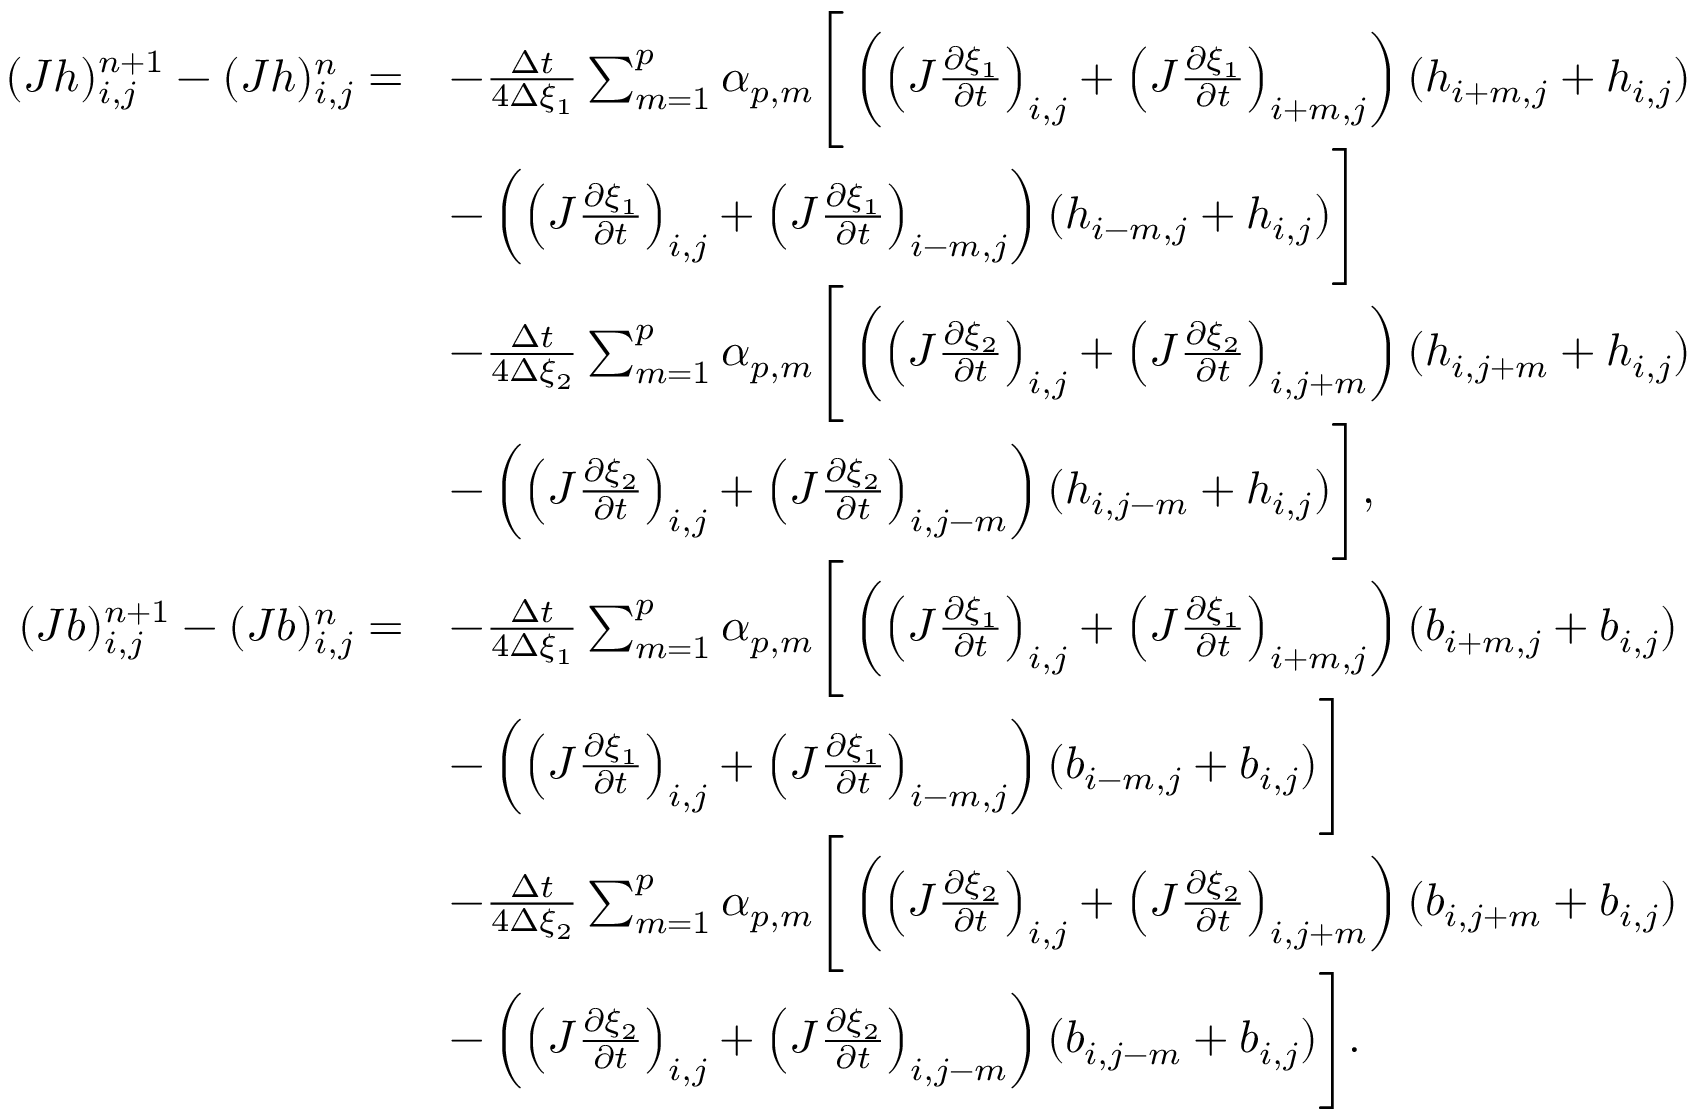Convert formula to latex. <formula><loc_0><loc_0><loc_500><loc_500>\begin{array} { r l } { ( J h ) _ { i , j } ^ { n + 1 } - ( J h ) _ { i , j } ^ { n } = } & { - \frac { \Delta t } { 4 \Delta { \xi _ { 1 } } } \sum _ { m = 1 } ^ { p } \alpha _ { p , m } \left [ \left ( \left ( J \frac { \partial \xi _ { 1 } } { \partial t } \right ) _ { i , j } + \left ( J \frac { \partial \xi _ { 1 } } { \partial t } \right ) _ { i + m , j } \right ) ( h _ { i + m , j } + h _ { i , j } ) } \\ & { - \left ( \left ( J \frac { \partial \xi _ { 1 } } { \partial t } \right ) _ { i , j } + \left ( J \frac { \partial \xi _ { 1 } } { \partial t } \right ) _ { i - m , j } \right ) ( h _ { i - m , j } + h _ { i , j } ) \right ] } \\ & { - \frac { \Delta t } { 4 \Delta { \xi _ { 2 } } } \sum _ { m = 1 } ^ { p } \alpha _ { p , m } \left [ \left ( \left ( J \frac { \partial \xi _ { 2 } } { \partial t } \right ) _ { i , j } + \left ( J \frac { \partial \xi _ { 2 } } { \partial t } \right ) _ { i , j + m } \right ) ( h _ { i , j + m } + h _ { i , j } ) } \\ & { - \left ( \left ( J \frac { \partial \xi _ { 2 } } { \partial t } \right ) _ { i , j } + \left ( J \frac { \partial \xi _ { 2 } } { \partial t } \right ) _ { i , j - m } \right ) ( h _ { i , j - m } + h _ { i , j } ) \right ] , } \\ { ( J b ) _ { i , j } ^ { n + 1 } - ( J b ) _ { i , j } ^ { n } = } & { - \frac { \Delta t } { 4 \Delta { \xi _ { 1 } } } \sum _ { m = 1 } ^ { p } \alpha _ { p , m } \left [ \left ( \left ( J \frac { \partial \xi _ { 1 } } { \partial t } \right ) _ { i , j } + \left ( J \frac { \partial \xi _ { 1 } } { \partial t } \right ) _ { i + m , j } \right ) ( b _ { i + m , j } + b _ { i , j } ) } \\ & { - \left ( \left ( J \frac { \partial \xi _ { 1 } } { \partial t } \right ) _ { i , j } + \left ( J \frac { \partial \xi _ { 1 } } { \partial t } \right ) _ { i - m , j } \right ) ( b _ { i - m , j } + b _ { i , j } ) \right ] } \\ & { - \frac { \Delta t } { 4 \Delta { \xi _ { 2 } } } \sum _ { m = 1 } ^ { p } \alpha _ { p , m } \left [ \left ( \left ( J \frac { \partial \xi _ { 2 } } { \partial t } \right ) _ { i , j } + \left ( J \frac { \partial \xi _ { 2 } } { \partial t } \right ) _ { i , j + m } \right ) ( b _ { i , j + m } + b _ { i , j } ) } \\ & { - \left ( \left ( J \frac { \partial \xi _ { 2 } } { \partial t } \right ) _ { i , j } + \left ( J \frac { \partial \xi _ { 2 } } { \partial t } \right ) _ { i , j - m } \right ) ( b _ { i , j - m } + b _ { i , j } ) \right ] . } \end{array}</formula> 